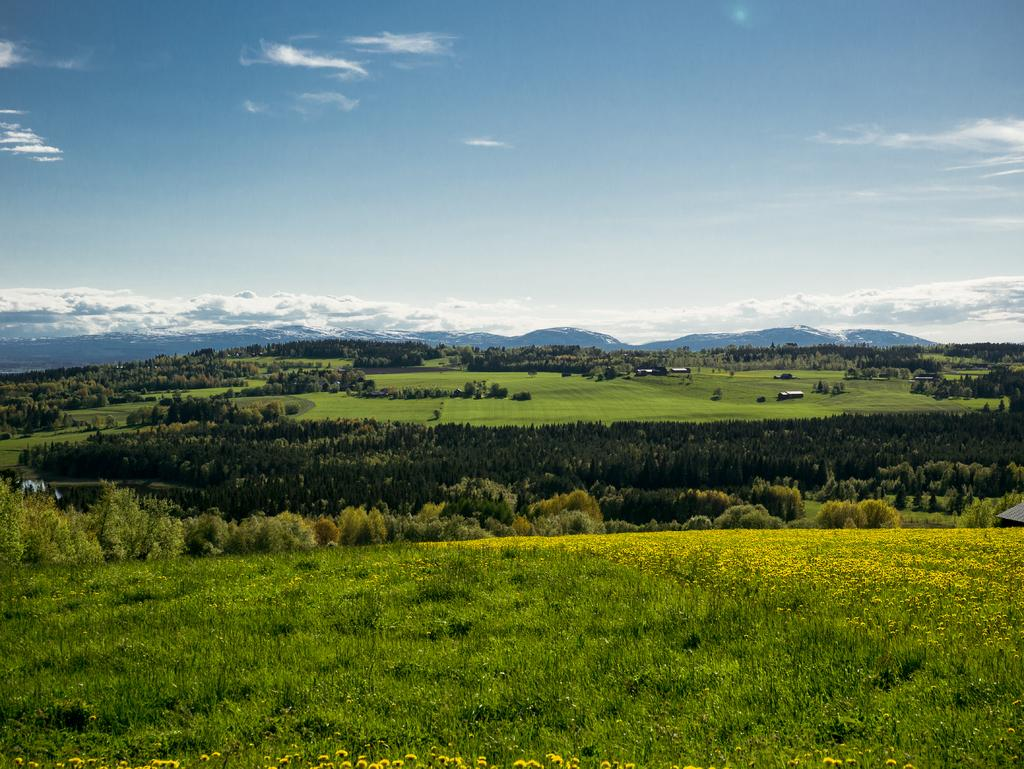What color is the sky in the image? The sky is blue in the image. What type of vegetation can be seen on the ground in the image? There is grass visible in the image. What other types of vegetation are present in the image? There are trees and plants in the image. What type of music is being played in the image? There is no indication of music being played in the image. What kind of society is depicted in the image? The image does not depict a society; it features natural elements such as the sky, grass, trees, and plants. 